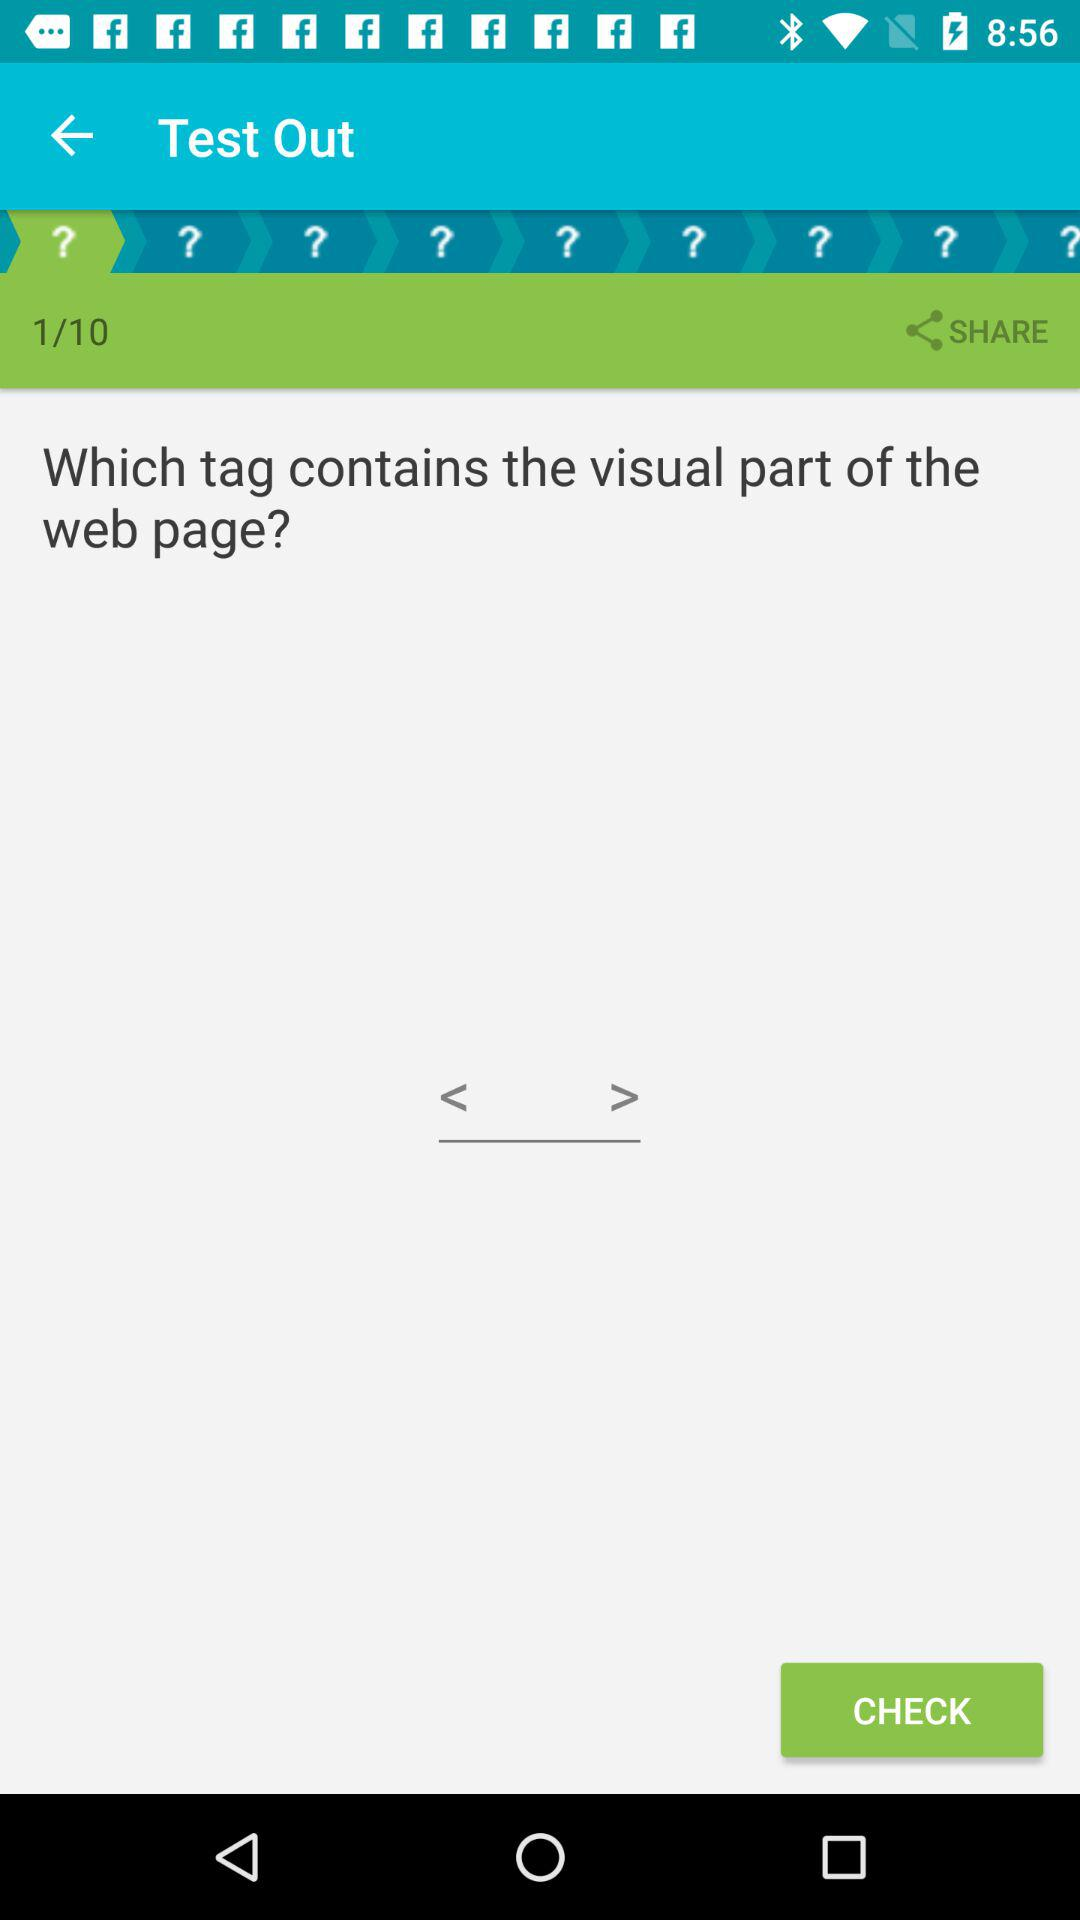How many question marks are there?
Answer the question using a single word or phrase. 10 